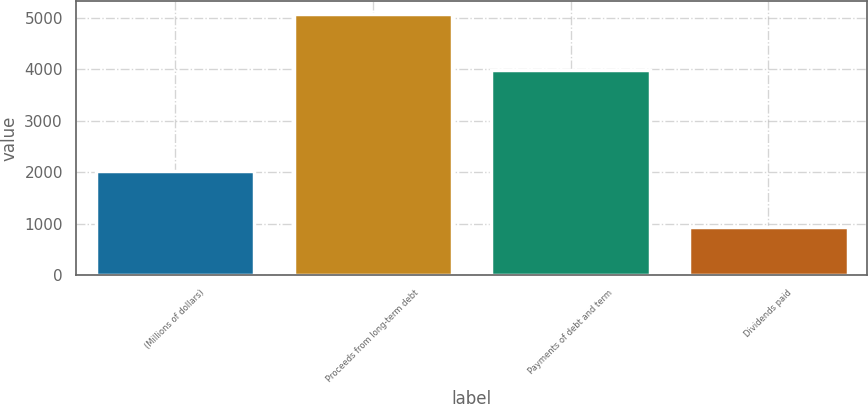<chart> <loc_0><loc_0><loc_500><loc_500><bar_chart><fcel>(Millions of dollars)<fcel>Proceeds from long-term debt<fcel>Payments of debt and term<fcel>Dividends paid<nl><fcel>2018<fcel>5086<fcel>3996<fcel>927<nl></chart> 